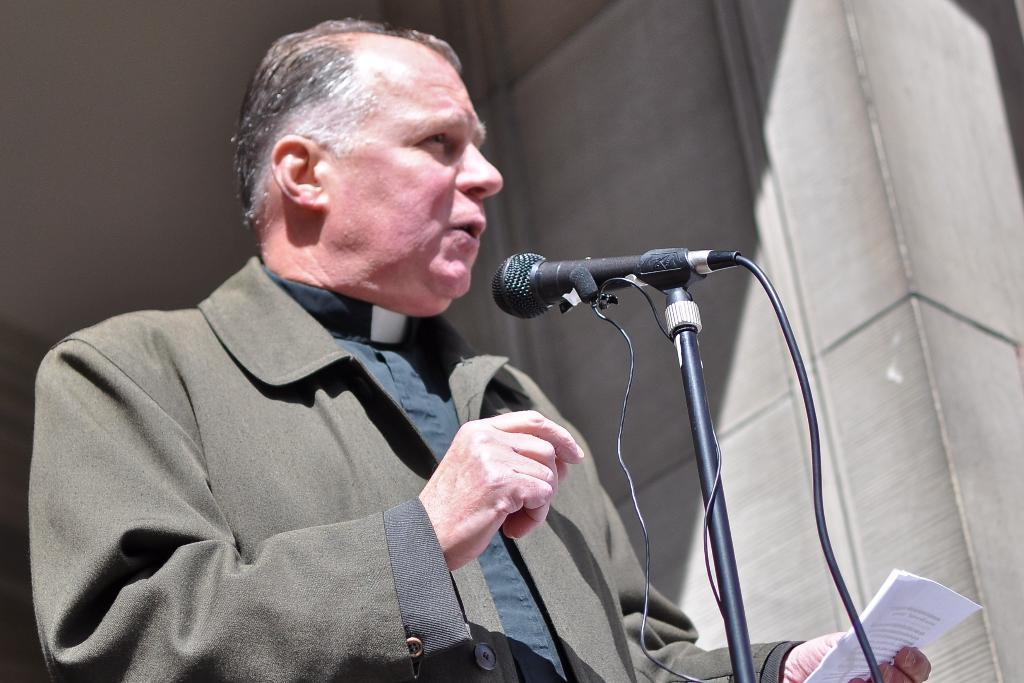What is the man in the image doing? The man is standing in the image. What is the man holding in his hand? The man is holding a paper in his hand. What object is placed in front of the man? There is a microphone placed in front of the man. What type of fang can be seen in the man's mouth in the image? There is no fang visible in the man's mouth in the image. How many letters are written on the paper the man is holding? We cannot determine the number of letters on the paper the man is holding from the image alone. 